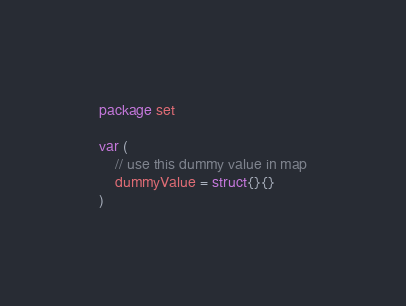Convert code to text. <code><loc_0><loc_0><loc_500><loc_500><_Go_>package set

var (
	// use this dummy value in map
	dummyValue = struct{}{}
)
</code> 